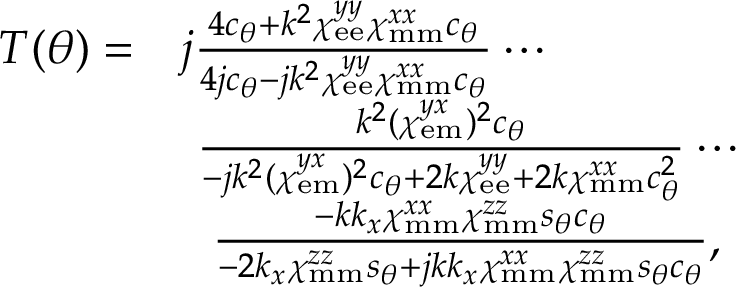Convert formula to latex. <formula><loc_0><loc_0><loc_500><loc_500>\begin{array} { r l } { T ( \theta ) = } & { j \frac { 4 c _ { \theta } + k ^ { 2 } \chi _ { e e } ^ { y y } \chi _ { m m } ^ { x x } c _ { \theta } } { 4 j c _ { \theta } - j k ^ { 2 } \chi _ { e e } ^ { y y } \chi _ { m m } ^ { x x } c _ { \theta } } \cdots } \\ & { \ \frac { k ^ { 2 } ( \chi _ { e m } ^ { y x } ) ^ { 2 } c _ { \theta } } { - j k ^ { 2 } ( \chi _ { e m } ^ { y x } ) ^ { 2 } c _ { \theta } + 2 k \chi _ { e e } ^ { y y } + 2 k \chi _ { m m } ^ { x x } c _ { \theta } ^ { 2 } } \cdots } \\ & { \quad f r a c { - k k _ { x } \chi _ { m m } ^ { x x } \chi _ { m m } ^ { z z } s _ { \theta } c _ { \theta } } { - 2 k _ { x } \chi _ { m m } ^ { z z } s _ { \theta } + j k k _ { x } \chi _ { m m } ^ { x x } \chi _ { m m } ^ { z z } s _ { \theta } c _ { \theta } } , } \end{array}</formula> 